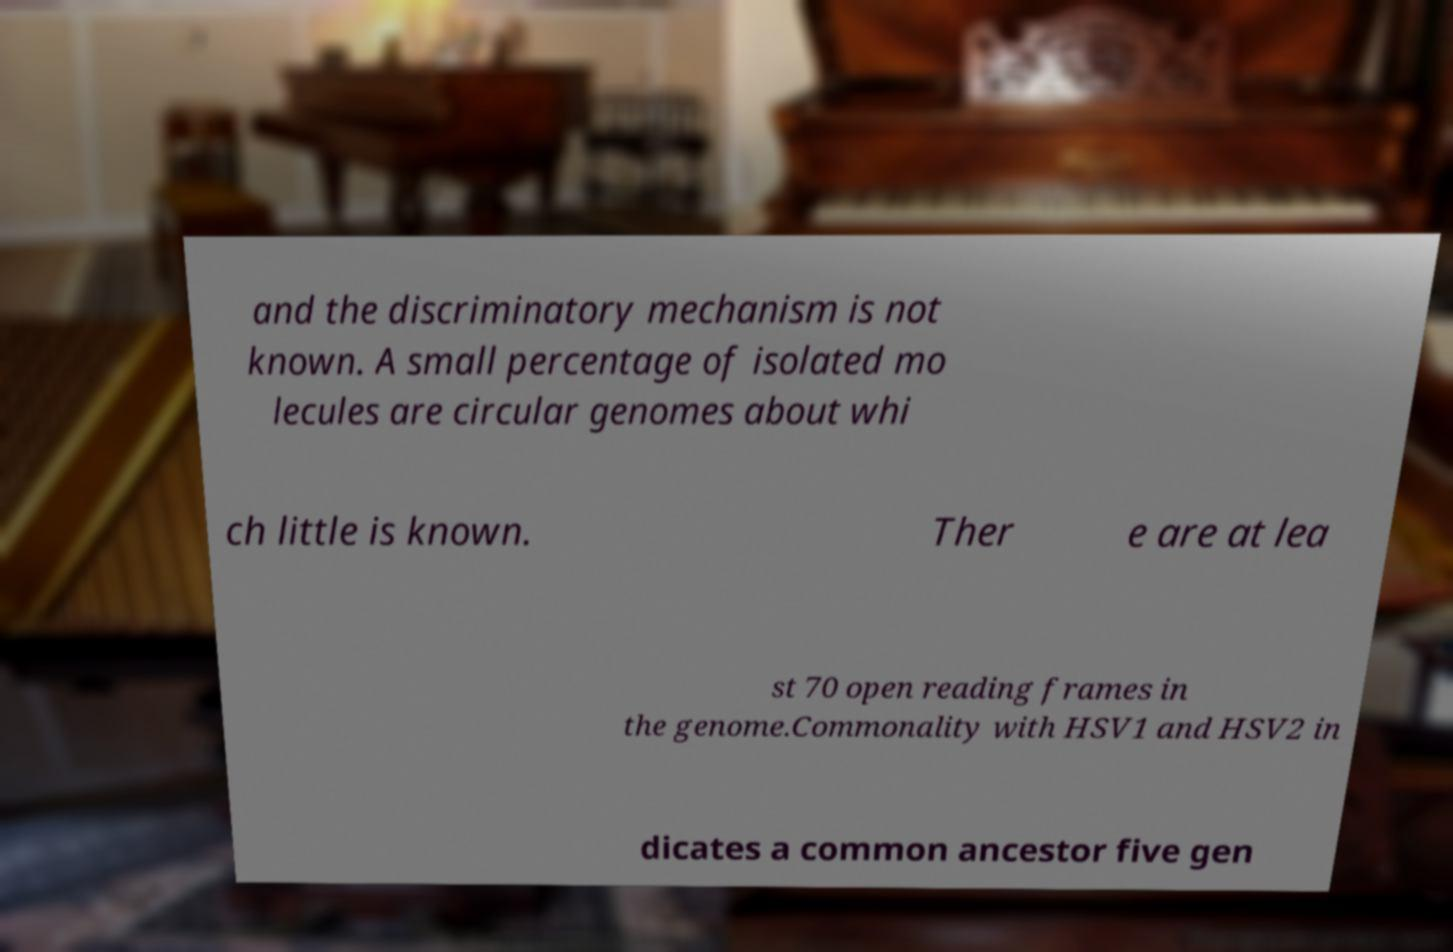Can you accurately transcribe the text from the provided image for me? and the discriminatory mechanism is not known. A small percentage of isolated mo lecules are circular genomes about whi ch little is known. Ther e are at lea st 70 open reading frames in the genome.Commonality with HSV1 and HSV2 in dicates a common ancestor five gen 